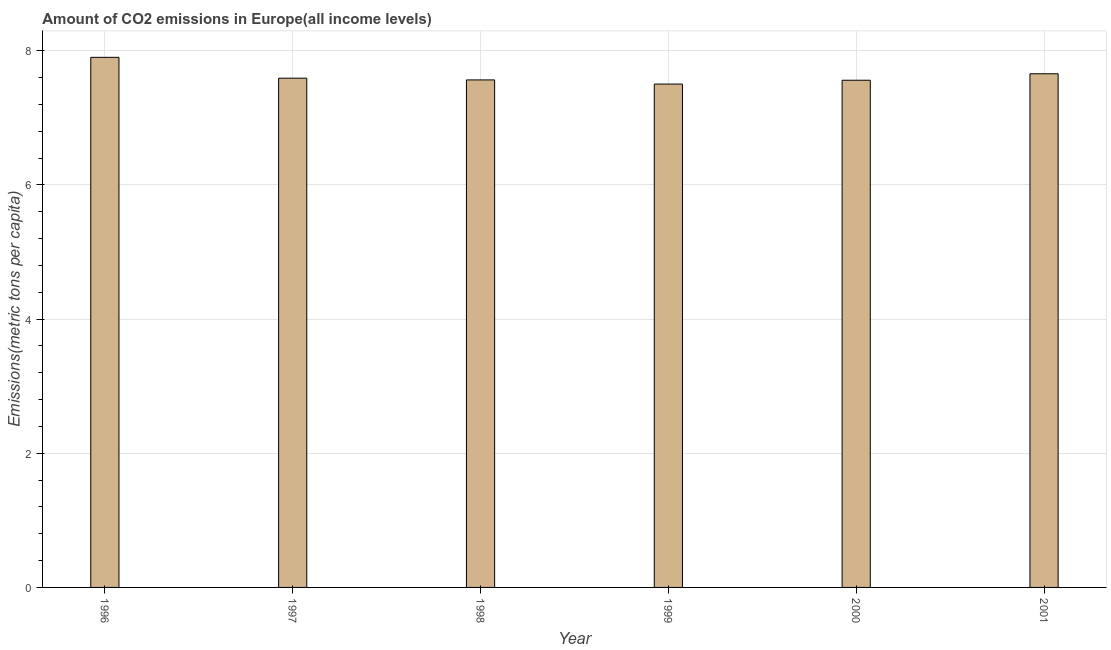Does the graph contain any zero values?
Provide a succinct answer. No. Does the graph contain grids?
Give a very brief answer. Yes. What is the title of the graph?
Provide a succinct answer. Amount of CO2 emissions in Europe(all income levels). What is the label or title of the X-axis?
Your answer should be very brief. Year. What is the label or title of the Y-axis?
Your answer should be very brief. Emissions(metric tons per capita). What is the amount of co2 emissions in 2000?
Keep it short and to the point. 7.56. Across all years, what is the maximum amount of co2 emissions?
Make the answer very short. 7.9. Across all years, what is the minimum amount of co2 emissions?
Your response must be concise. 7.5. In which year was the amount of co2 emissions maximum?
Offer a terse response. 1996. What is the sum of the amount of co2 emissions?
Your answer should be compact. 45.77. What is the difference between the amount of co2 emissions in 1998 and 1999?
Make the answer very short. 0.06. What is the average amount of co2 emissions per year?
Your answer should be compact. 7.63. What is the median amount of co2 emissions?
Your answer should be very brief. 7.58. In how many years, is the amount of co2 emissions greater than 4.8 metric tons per capita?
Ensure brevity in your answer.  6. Do a majority of the years between 1999 and 2001 (inclusive) have amount of co2 emissions greater than 1.6 metric tons per capita?
Provide a succinct answer. Yes. Is the amount of co2 emissions in 1997 less than that in 1999?
Provide a succinct answer. No. What is the difference between the highest and the second highest amount of co2 emissions?
Ensure brevity in your answer.  0.24. Is the sum of the amount of co2 emissions in 1996 and 1998 greater than the maximum amount of co2 emissions across all years?
Make the answer very short. Yes. What is the difference between the highest and the lowest amount of co2 emissions?
Your response must be concise. 0.4. In how many years, is the amount of co2 emissions greater than the average amount of co2 emissions taken over all years?
Provide a succinct answer. 2. Are all the bars in the graph horizontal?
Ensure brevity in your answer.  No. How many years are there in the graph?
Keep it short and to the point. 6. What is the difference between two consecutive major ticks on the Y-axis?
Make the answer very short. 2. What is the Emissions(metric tons per capita) in 1996?
Make the answer very short. 7.9. What is the Emissions(metric tons per capita) in 1997?
Your answer should be very brief. 7.59. What is the Emissions(metric tons per capita) in 1998?
Your answer should be compact. 7.56. What is the Emissions(metric tons per capita) in 1999?
Provide a succinct answer. 7.5. What is the Emissions(metric tons per capita) in 2000?
Offer a terse response. 7.56. What is the Emissions(metric tons per capita) in 2001?
Your answer should be very brief. 7.66. What is the difference between the Emissions(metric tons per capita) in 1996 and 1997?
Your response must be concise. 0.31. What is the difference between the Emissions(metric tons per capita) in 1996 and 1998?
Provide a succinct answer. 0.34. What is the difference between the Emissions(metric tons per capita) in 1996 and 1999?
Your answer should be compact. 0.4. What is the difference between the Emissions(metric tons per capita) in 1996 and 2000?
Make the answer very short. 0.34. What is the difference between the Emissions(metric tons per capita) in 1996 and 2001?
Your response must be concise. 0.24. What is the difference between the Emissions(metric tons per capita) in 1997 and 1998?
Offer a very short reply. 0.03. What is the difference between the Emissions(metric tons per capita) in 1997 and 1999?
Your answer should be compact. 0.09. What is the difference between the Emissions(metric tons per capita) in 1997 and 2000?
Offer a terse response. 0.03. What is the difference between the Emissions(metric tons per capita) in 1997 and 2001?
Offer a terse response. -0.07. What is the difference between the Emissions(metric tons per capita) in 1998 and 1999?
Ensure brevity in your answer.  0.06. What is the difference between the Emissions(metric tons per capita) in 1998 and 2000?
Make the answer very short. 0.01. What is the difference between the Emissions(metric tons per capita) in 1998 and 2001?
Provide a short and direct response. -0.09. What is the difference between the Emissions(metric tons per capita) in 1999 and 2000?
Your answer should be compact. -0.06. What is the difference between the Emissions(metric tons per capita) in 1999 and 2001?
Offer a terse response. -0.15. What is the difference between the Emissions(metric tons per capita) in 2000 and 2001?
Offer a very short reply. -0.1. What is the ratio of the Emissions(metric tons per capita) in 1996 to that in 1997?
Offer a terse response. 1.04. What is the ratio of the Emissions(metric tons per capita) in 1996 to that in 1998?
Offer a terse response. 1.04. What is the ratio of the Emissions(metric tons per capita) in 1996 to that in 1999?
Offer a terse response. 1.05. What is the ratio of the Emissions(metric tons per capita) in 1996 to that in 2000?
Give a very brief answer. 1.04. What is the ratio of the Emissions(metric tons per capita) in 1996 to that in 2001?
Your answer should be compact. 1.03. What is the ratio of the Emissions(metric tons per capita) in 1997 to that in 1998?
Provide a short and direct response. 1. What is the ratio of the Emissions(metric tons per capita) in 1997 to that in 1999?
Keep it short and to the point. 1.01. What is the ratio of the Emissions(metric tons per capita) in 1997 to that in 2001?
Ensure brevity in your answer.  0.99. What is the ratio of the Emissions(metric tons per capita) in 1998 to that in 1999?
Your answer should be very brief. 1.01. What is the ratio of the Emissions(metric tons per capita) in 1998 to that in 2001?
Provide a succinct answer. 0.99. What is the ratio of the Emissions(metric tons per capita) in 1999 to that in 2000?
Give a very brief answer. 0.99. 